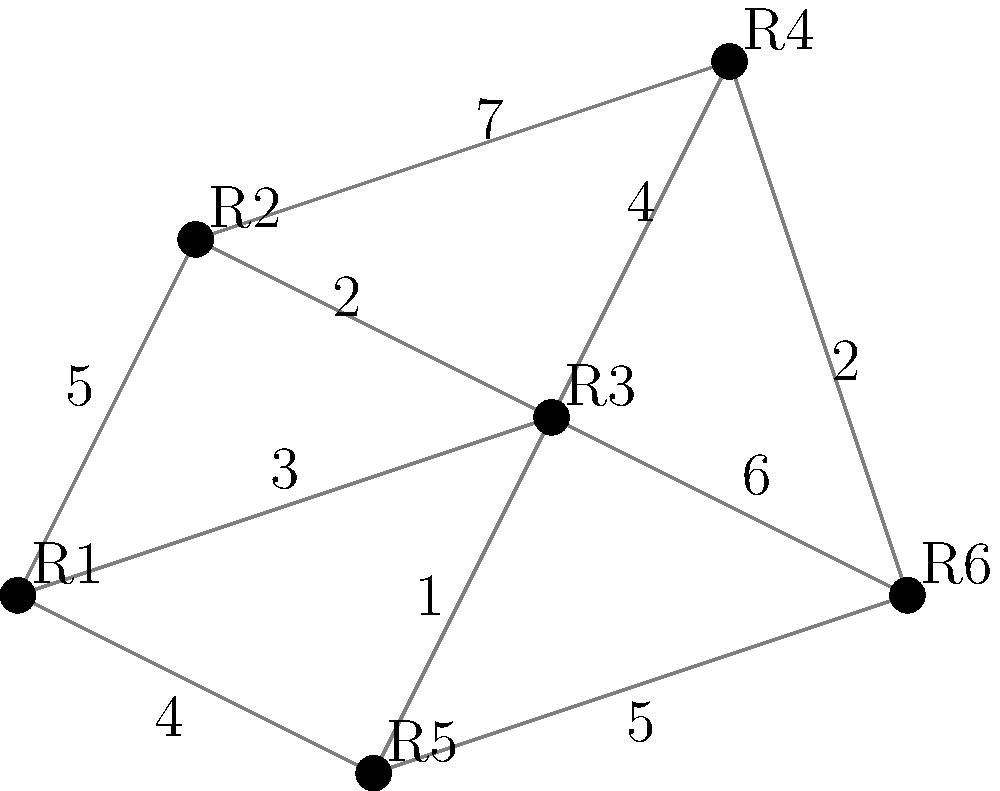As a location-based app creator, you need to design an efficient infrastructure to connect app users across different regions. The graph represents six regions (R1 to R6) and the cost of establishing connections between them. Using Kruskal's algorithm to find the minimum spanning tree, what is the total cost of the most efficient infrastructure that connects all regions? To solve this problem, we'll use Kruskal's algorithm to find the minimum spanning tree:

1. Sort all edges by weight in ascending order:
   (R2-R5): 1
   (R2-R3): 2
   (R4-R6): 2
   (R1-R3): 3
   (R1-R5): 4
   (R2-R4): 4
   (R1-R2): 5
   (R5-R6): 5
   (R3-R6): 6
   (R2-R4): 7

2. Start with an empty set of edges and add edges in order, skipping those that would create a cycle:

   a. Add (R2-R5): 1
   b. Add (R2-R3): 2
   c. Add (R4-R6): 2
   d. Add (R1-R3): 3
   e. Skip (R1-R5) as it would create a cycle
   f. Skip (R2-R4) as it would create a cycle
   g. Skip (R1-R2) as it would create a cycle
   h. Skip (R5-R6) as it would create a cycle
   i. Skip (R3-R6) as it would create a cycle
   j. Skip (R2-R4) as it would create a cycle

3. The minimum spanning tree is now complete with 5 edges.

4. Calculate the total cost by summing the weights of the selected edges:
   $1 + 2 + 2 + 3 = 8$

Therefore, the total cost of the most efficient infrastructure that connects all regions is 8.
Answer: 8 